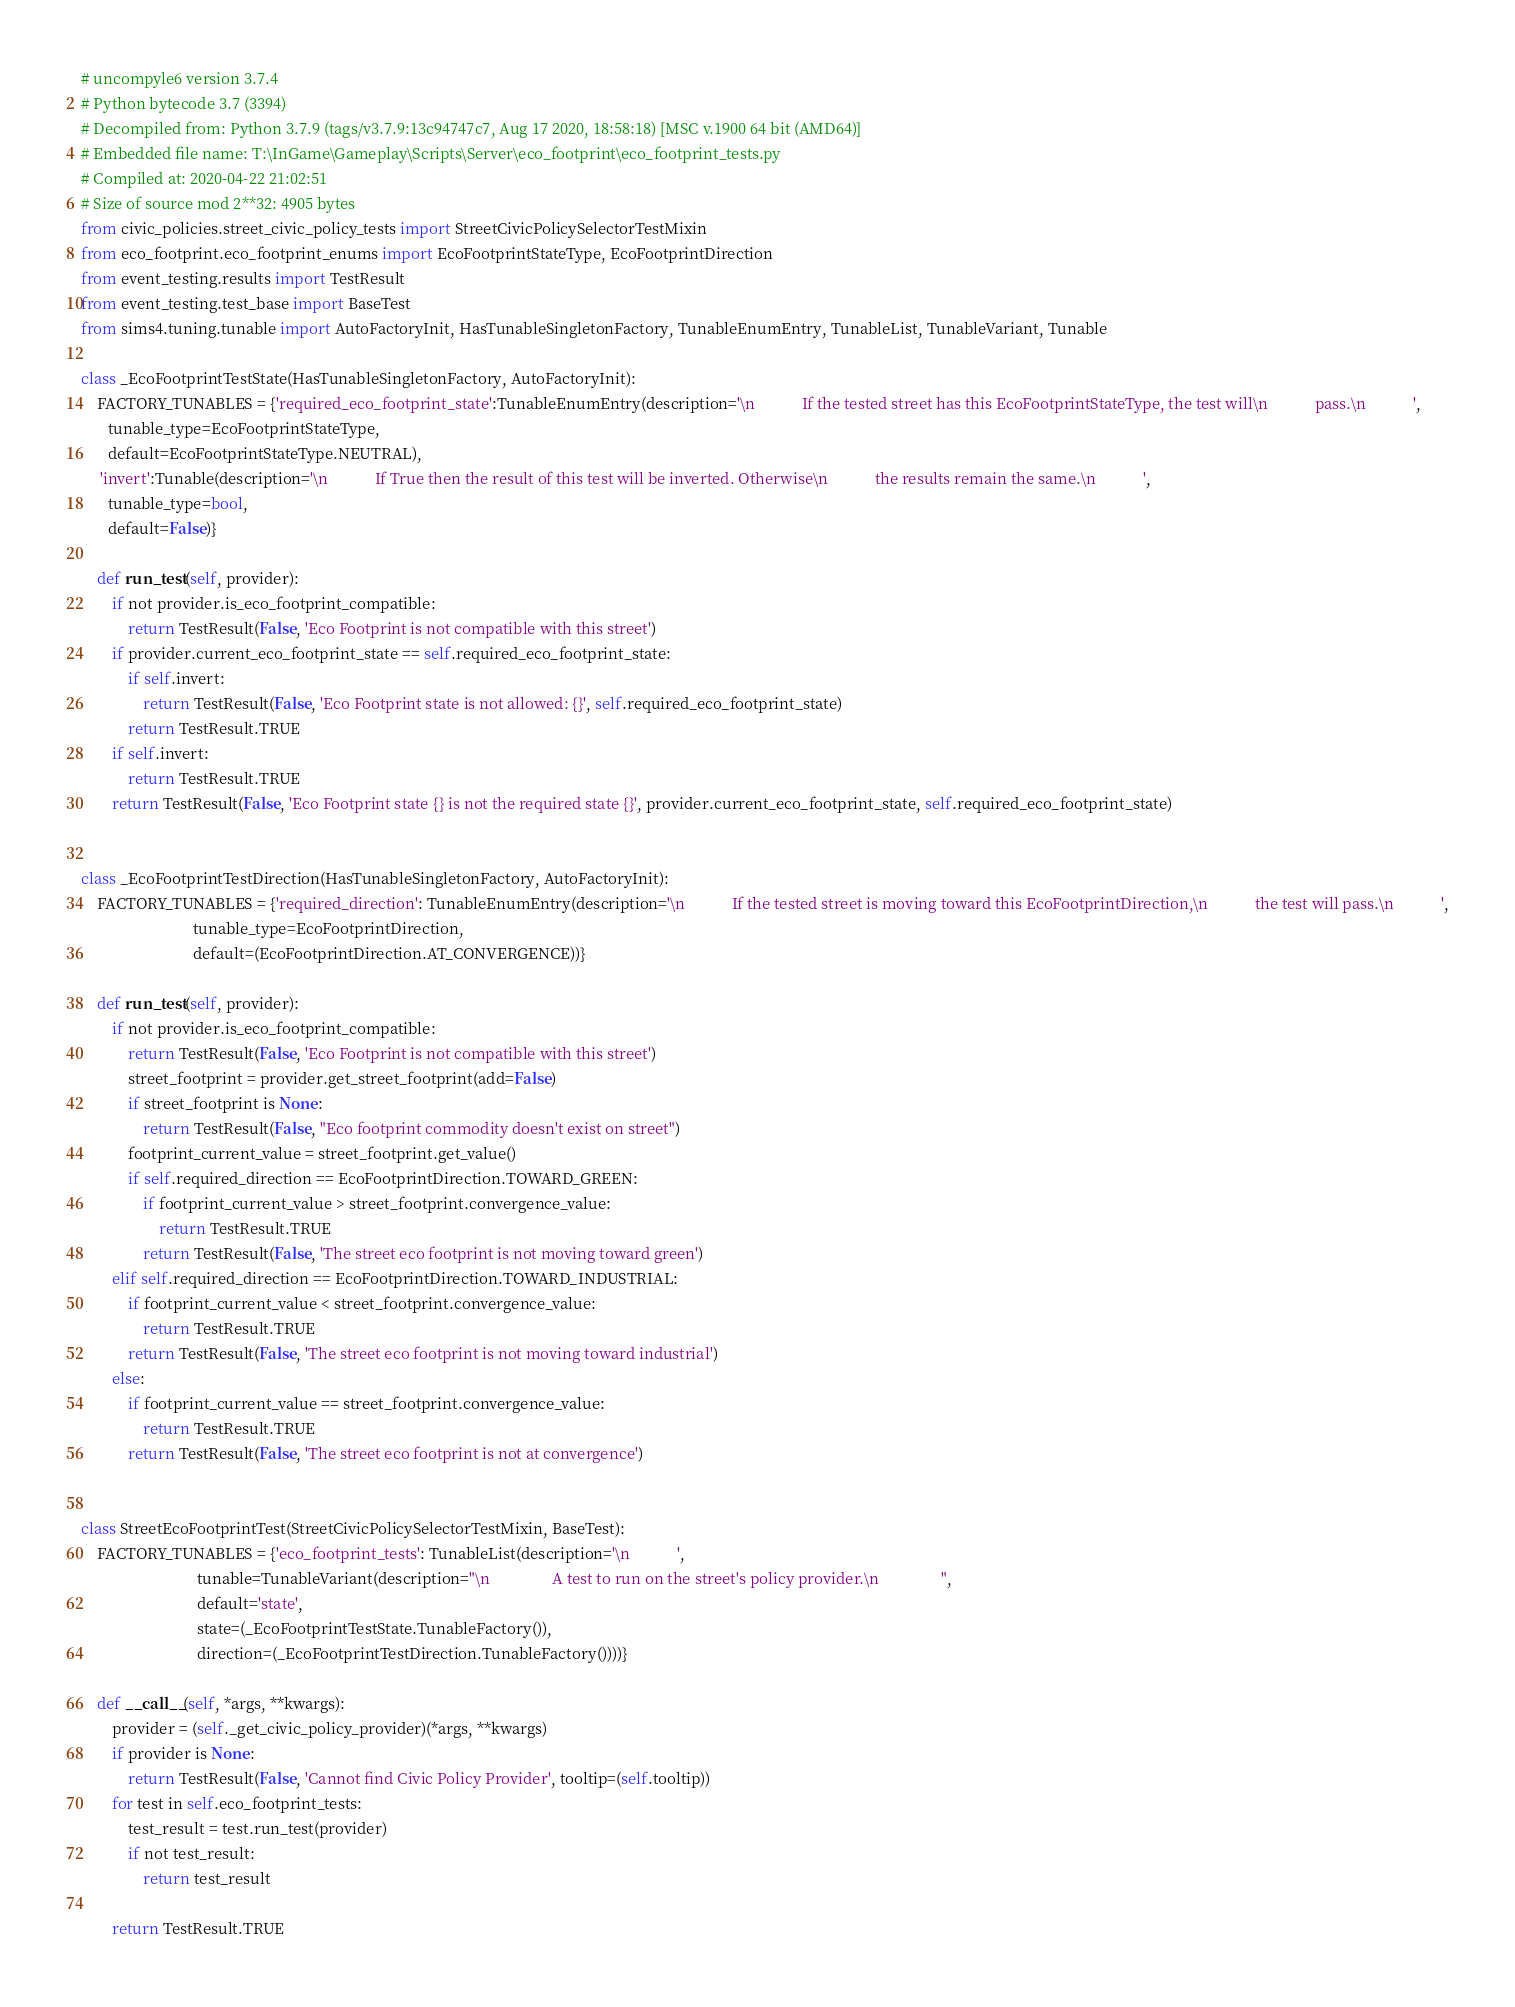<code> <loc_0><loc_0><loc_500><loc_500><_Python_># uncompyle6 version 3.7.4
# Python bytecode 3.7 (3394)
# Decompiled from: Python 3.7.9 (tags/v3.7.9:13c94747c7, Aug 17 2020, 18:58:18) [MSC v.1900 64 bit (AMD64)]
# Embedded file name: T:\InGame\Gameplay\Scripts\Server\eco_footprint\eco_footprint_tests.py
# Compiled at: 2020-04-22 21:02:51
# Size of source mod 2**32: 4905 bytes
from civic_policies.street_civic_policy_tests import StreetCivicPolicySelectorTestMixin
from eco_footprint.eco_footprint_enums import EcoFootprintStateType, EcoFootprintDirection
from event_testing.results import TestResult
from event_testing.test_base import BaseTest
from sims4.tuning.tunable import AutoFactoryInit, HasTunableSingletonFactory, TunableEnumEntry, TunableList, TunableVariant, Tunable

class _EcoFootprintTestState(HasTunableSingletonFactory, AutoFactoryInit):
    FACTORY_TUNABLES = {'required_eco_footprint_state':TunableEnumEntry(description='\n            If the tested street has this EcoFootprintStateType, the test will\n            pass.\n            ',
       tunable_type=EcoFootprintStateType,
       default=EcoFootprintStateType.NEUTRAL), 
     'invert':Tunable(description='\n            If True then the result of this test will be inverted. Otherwise\n            the results remain the same.\n            ',
       tunable_type=bool,
       default=False)}

    def run_test(self, provider):
        if not provider.is_eco_footprint_compatible:
            return TestResult(False, 'Eco Footprint is not compatible with this street')
        if provider.current_eco_footprint_state == self.required_eco_footprint_state:
            if self.invert:
                return TestResult(False, 'Eco Footprint state is not allowed: {}', self.required_eco_footprint_state)
            return TestResult.TRUE
        if self.invert:
            return TestResult.TRUE
        return TestResult(False, 'Eco Footprint state {} is not the required state {}', provider.current_eco_footprint_state, self.required_eco_footprint_state)


class _EcoFootprintTestDirection(HasTunableSingletonFactory, AutoFactoryInit):
    FACTORY_TUNABLES = {'required_direction': TunableEnumEntry(description='\n            If the tested street is moving toward this EcoFootprintDirection,\n            the test will pass.\n            ',
                             tunable_type=EcoFootprintDirection,
                             default=(EcoFootprintDirection.AT_CONVERGENCE))}

    def run_test(self, provider):
        if not provider.is_eco_footprint_compatible:
            return TestResult(False, 'Eco Footprint is not compatible with this street')
            street_footprint = provider.get_street_footprint(add=False)
            if street_footprint is None:
                return TestResult(False, "Eco footprint commodity doesn't exist on street")
            footprint_current_value = street_footprint.get_value()
            if self.required_direction == EcoFootprintDirection.TOWARD_GREEN:
                if footprint_current_value > street_footprint.convergence_value:
                    return TestResult.TRUE
                return TestResult(False, 'The street eco footprint is not moving toward green')
        elif self.required_direction == EcoFootprintDirection.TOWARD_INDUSTRIAL:
            if footprint_current_value < street_footprint.convergence_value:
                return TestResult.TRUE
            return TestResult(False, 'The street eco footprint is not moving toward industrial')
        else:
            if footprint_current_value == street_footprint.convergence_value:
                return TestResult.TRUE
            return TestResult(False, 'The street eco footprint is not at convergence')


class StreetEcoFootprintTest(StreetCivicPolicySelectorTestMixin, BaseTest):
    FACTORY_TUNABLES = {'eco_footprint_tests': TunableList(description='\n            ',
                              tunable=TunableVariant(description="\n                A test to run on the street's policy provider.\n                ",
                              default='state',
                              state=(_EcoFootprintTestState.TunableFactory()),
                              direction=(_EcoFootprintTestDirection.TunableFactory())))}

    def __call__(self, *args, **kwargs):
        provider = (self._get_civic_policy_provider)(*args, **kwargs)
        if provider is None:
            return TestResult(False, 'Cannot find Civic Policy Provider', tooltip=(self.tooltip))
        for test in self.eco_footprint_tests:
            test_result = test.run_test(provider)
            if not test_result:
                return test_result

        return TestResult.TRUE</code> 